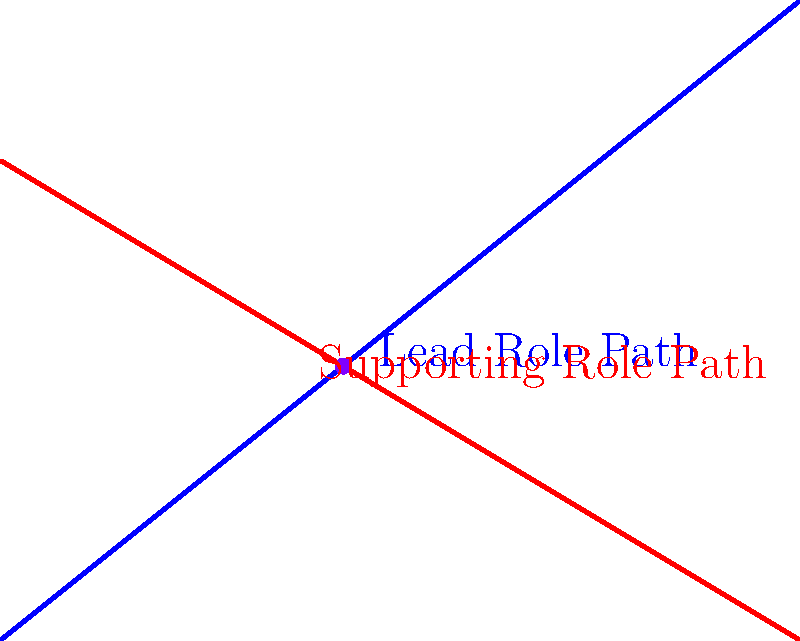In your acting career, you're faced with two potential paths: pursuing a lead role (represented by the blue line) or accepting a supporting role (represented by the red line). The lead role path can be described by the equation $y = 0.8x$, while the supporting role path is given by $y = -0.6x + 6$. At what point do these career paths intersect, potentially forcing you to make a crucial decision? To find the intersection point of these two career paths, we need to solve the system of equations:

1) Lead role path: $y = 0.8x$
2) Supporting role path: $y = -0.6x + 6$

Step 1: Set the equations equal to each other
$0.8x = -0.6x + 6$

Step 2: Add $0.6x$ to both sides
$1.4x = 6$

Step 3: Divide both sides by 1.4
$x = \frac{6}{1.4} = \frac{30}{7} \approx 4.29$

Step 4: Substitute this x-value into either equation to find y
Using the lead role equation: $y = 0.8(\frac{30}{7}) = \frac{24}{7} \approx 3.43$

Step 5: Round to the nearest whole number
The intersection point is approximately (5, 4).

This point represents the moment in your career where you must decide between continuing on the lead role path or switching to the supporting role path.
Answer: (5, 4) 